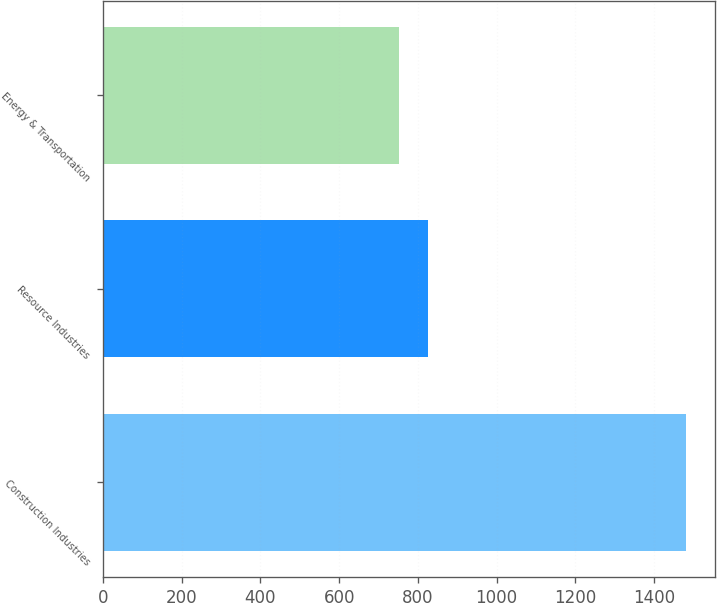<chart> <loc_0><loc_0><loc_500><loc_500><bar_chart><fcel>Construction Industries<fcel>Resource Industries<fcel>Energy & Transportation<nl><fcel>1480<fcel>825.7<fcel>753<nl></chart> 